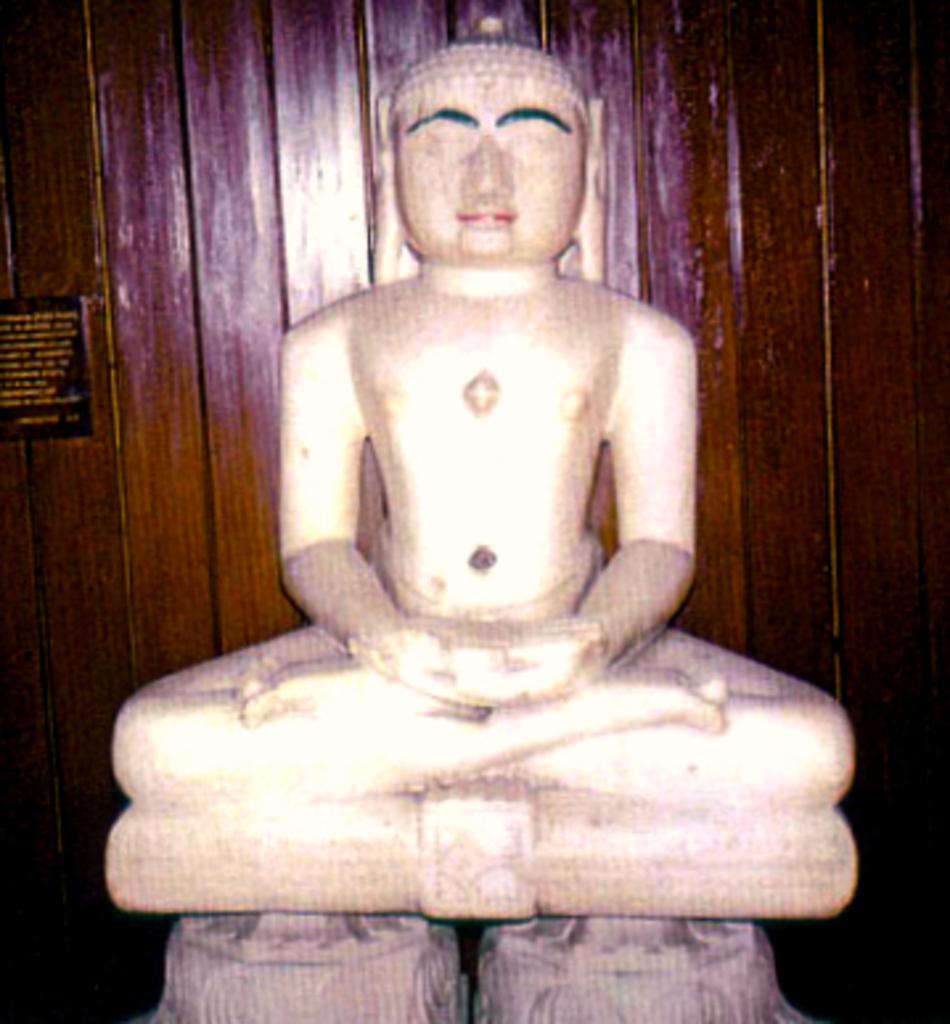How would you summarize this image in a sentence or two? In this image I can see a white color statue. Background is in brown color. 